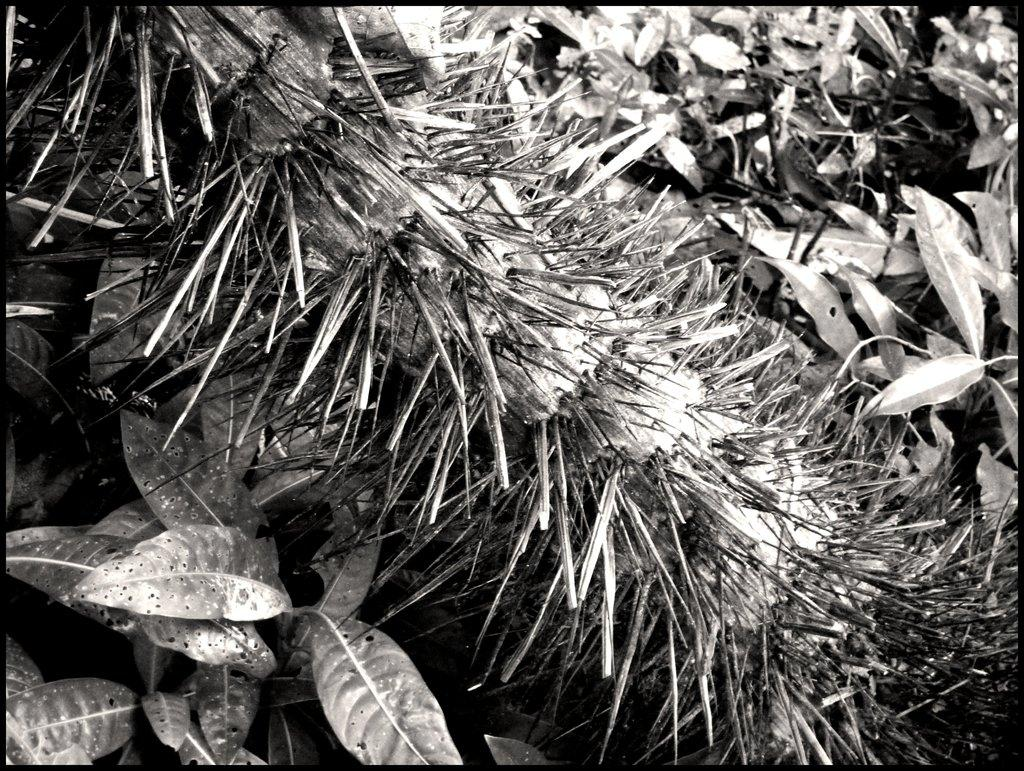What type of living organisms can be seen in the image? Plants can be seen in the image. What is the color scheme of the image? The image is black and white in color. Can you see a worm crawling on the plants in the image? There is no worm present in the image; only plants are visible. What type of blade is being used to trim the plants in the image? There is no blade or trimming activity depicted in the image; it only shows plants. 